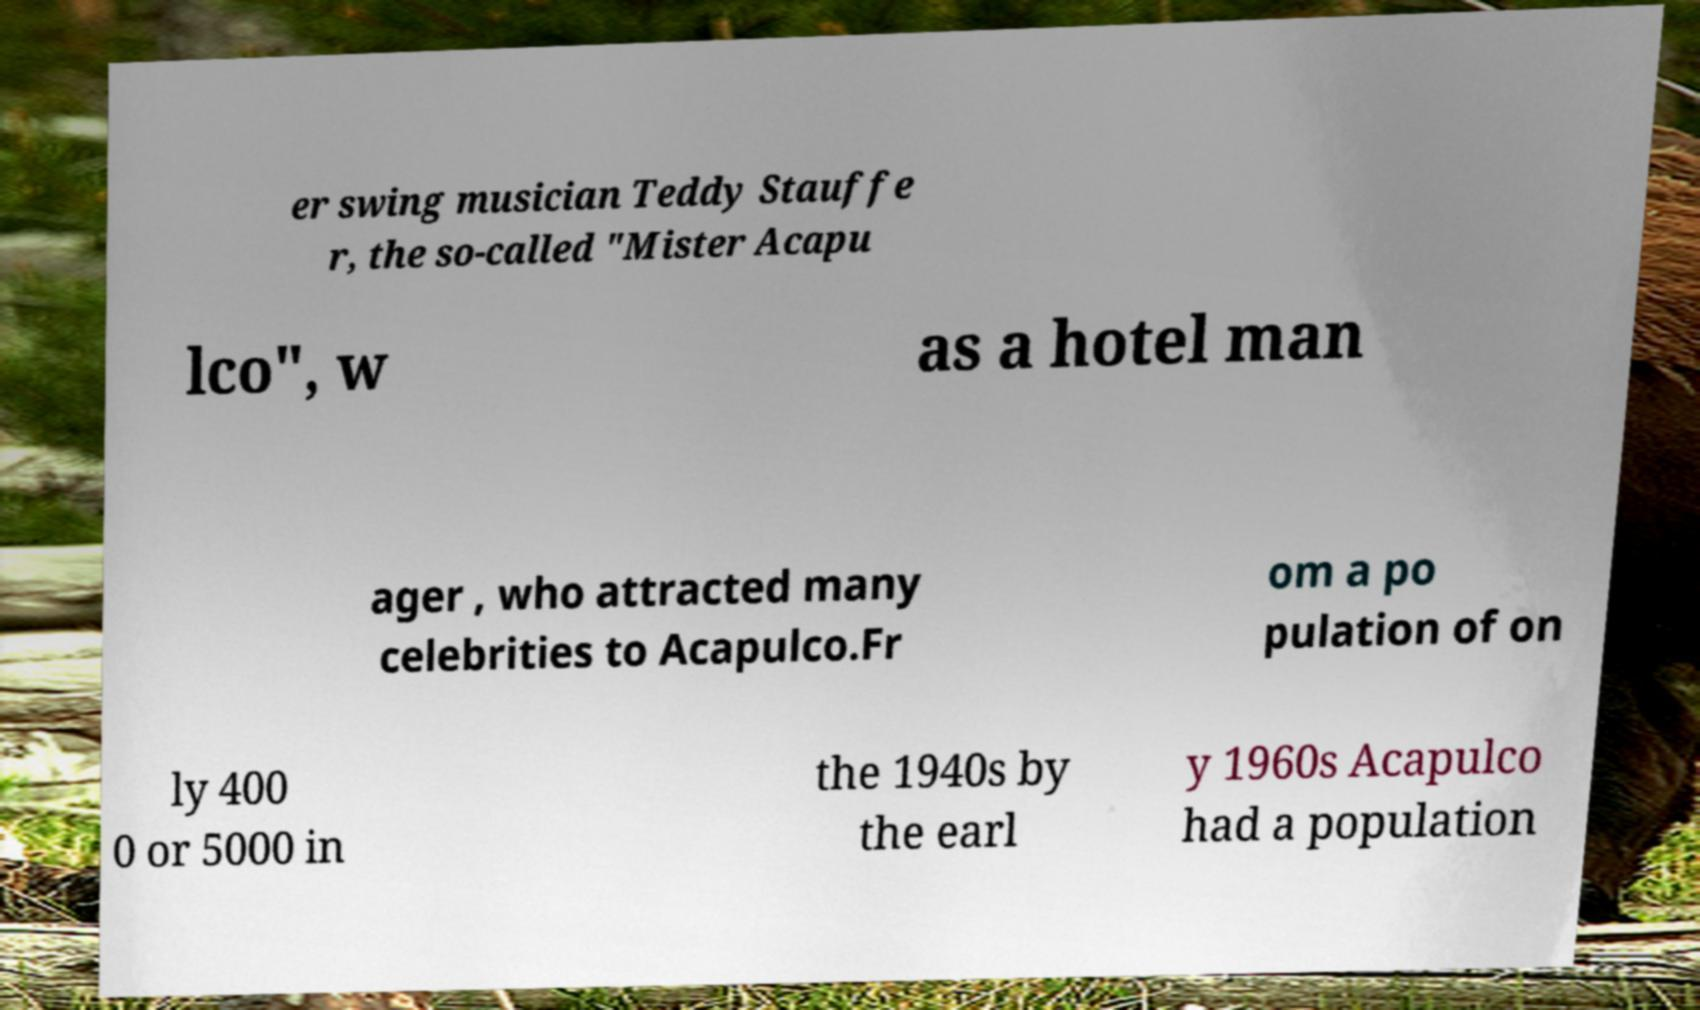What messages or text are displayed in this image? I need them in a readable, typed format. er swing musician Teddy Stauffe r, the so-called "Mister Acapu lco", w as a hotel man ager , who attracted many celebrities to Acapulco.Fr om a po pulation of on ly 400 0 or 5000 in the 1940s by the earl y 1960s Acapulco had a population 